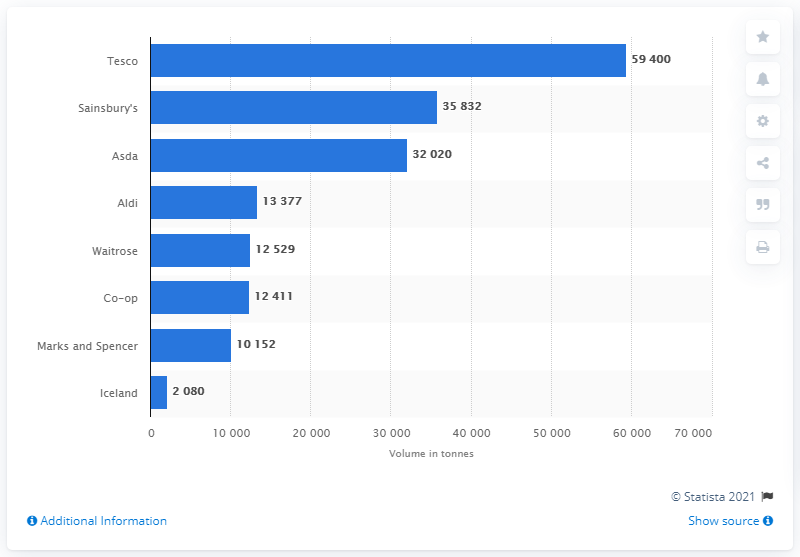Point out several critical features in this image. The supermarket that generated the highest amount of food waste in 2016 was Tesco. Sainsbury's waste generation in 2016 was reported to be 35,832 metric tons. 